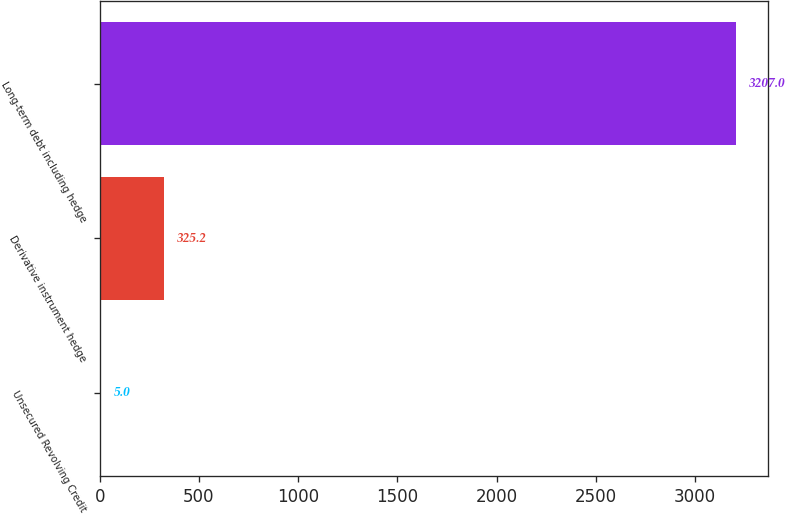Convert chart to OTSL. <chart><loc_0><loc_0><loc_500><loc_500><bar_chart><fcel>Unsecured Revolving Credit<fcel>Derivative instrument hedge<fcel>Long-term debt including hedge<nl><fcel>5<fcel>325.2<fcel>3207<nl></chart> 